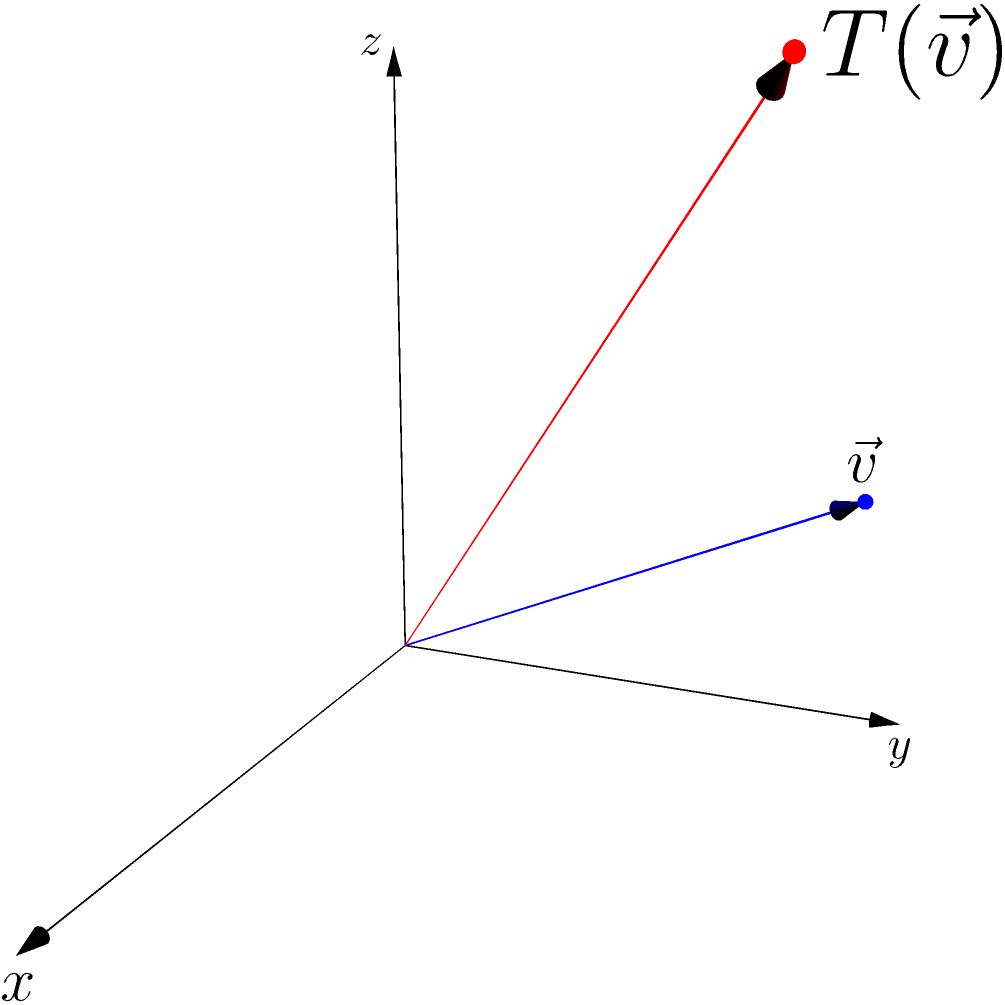Given a linguistic feature vector $\vec{v} = (2, 3, 1)$ in a 3D coordinate system, it undergoes a linear transformation $T$ defined by the matrix:

$$T = \begin{bmatrix}
2 & 0 & 0 \\
0 & 1 & 0 \\
0 & 0 & 2
\end{bmatrix}$$

What is the resulting vector $T(\vec{v})$ after the transformation? To find the transformed vector $T(\vec{v})$, we need to multiply the transformation matrix $T$ by the original vector $\vec{v}$. Let's go through this step-by-step:

1) First, let's write out the matrix multiplication:

   $$T(\vec{v}) = \begin{bmatrix}
   2 & 0 & 0 \\
   0 & 1 & 0 \\
   0 & 0 & 2
   \end{bmatrix} \begin{bmatrix}
   2 \\
   3 \\
   1
   \end{bmatrix}$$

2) Now, let's perform the matrix multiplication:

   - For the x-component: $(2 \times 2) + (0 \times 3) + (0 \times 1) = 4$
   - For the y-component: $(0 \times 2) + (1 \times 3) + (0 \times 1) = 3$
   - For the z-component: $(0 \times 2) + (0 \times 3) + (2 \times 1) = 2$

3) Therefore, the resulting vector is:

   $$T(\vec{v}) = \begin{bmatrix}
   4 \\
   3 \\
   2
   \end{bmatrix}$$

This transformation scales the x-component by 2, leaves the y-component unchanged, and scales the z-component by 2. In the context of linguistic feature vectors, this could represent an emphasis on certain linguistic features (x and z) while maintaining others (y).
Answer: $(4, 3, 2)$ 